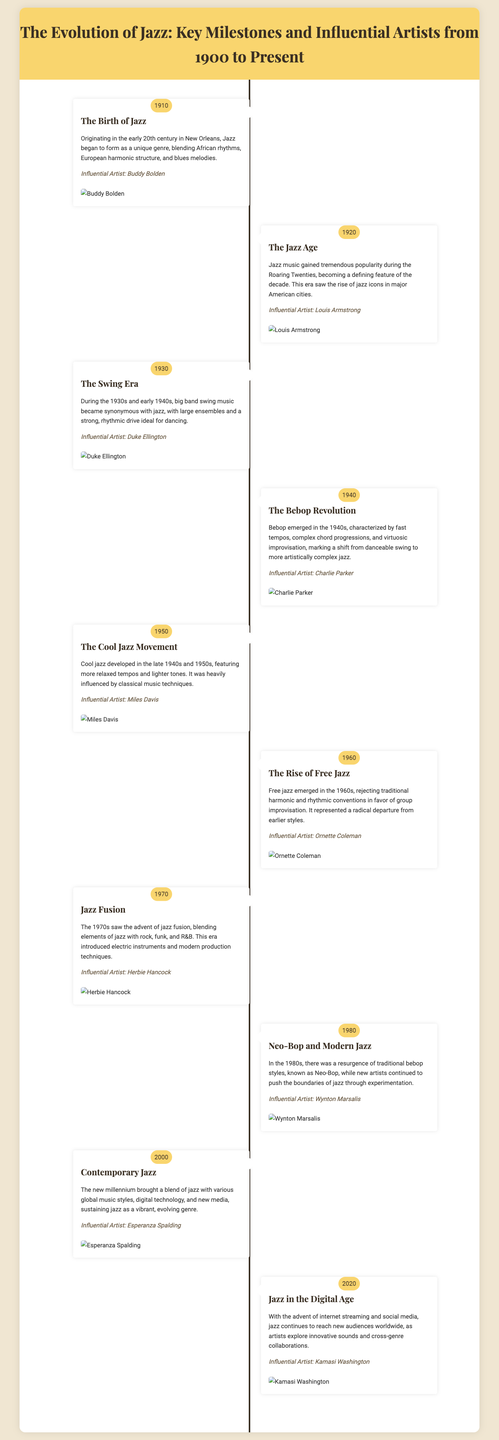What year marks the birth of Jazz? The document states that jazz began to form as a unique genre in the early 20th century, specifically mentioning the year 1910.
Answer: 1910 Who is an influential artist from the Jazz Age? The timeline indicates that Louis Armstrong was a significant figure during the Jazz Age.
Answer: Louis Armstrong What musical movement emerged in the 1940s? The timeline describes the Bebop Revolution as the musical movement that characterized the 1940s.
Answer: Bebop Revolution Which influential artist is associated with the Cool Jazz Movement? The document lists Miles Davis as a key artist in the Cool Jazz Movement, which developed in the late 1940s and 1950s.
Answer: Miles Davis In what decade did Jazz Fusion emerge? According to the timeline, jazz fusion began to take shape in the 1970s.
Answer: 1970s What significant development in jazz occurred in the 1960s? The timeline notes that the rise of free jazz, known for its radical departure from earlier styles, took place in the 1960s.
Answer: Free Jazz Who is featured as an influential artist in 2020? The document mentions Kamasi Washington as an influential artist in the year 2020.
Answer: Kamasi Washington What genre blend does contemporary jazz incorporate? The document states that contemporary jazz includes a mix of jazz with various global music styles and digital technology.
Answer: Global music styles What year did the Swing Era occur? The timeline specifies that the Swing Era took place during the decade of the 1930s and early 1940s.
Answer: 1930s and early 1940s 